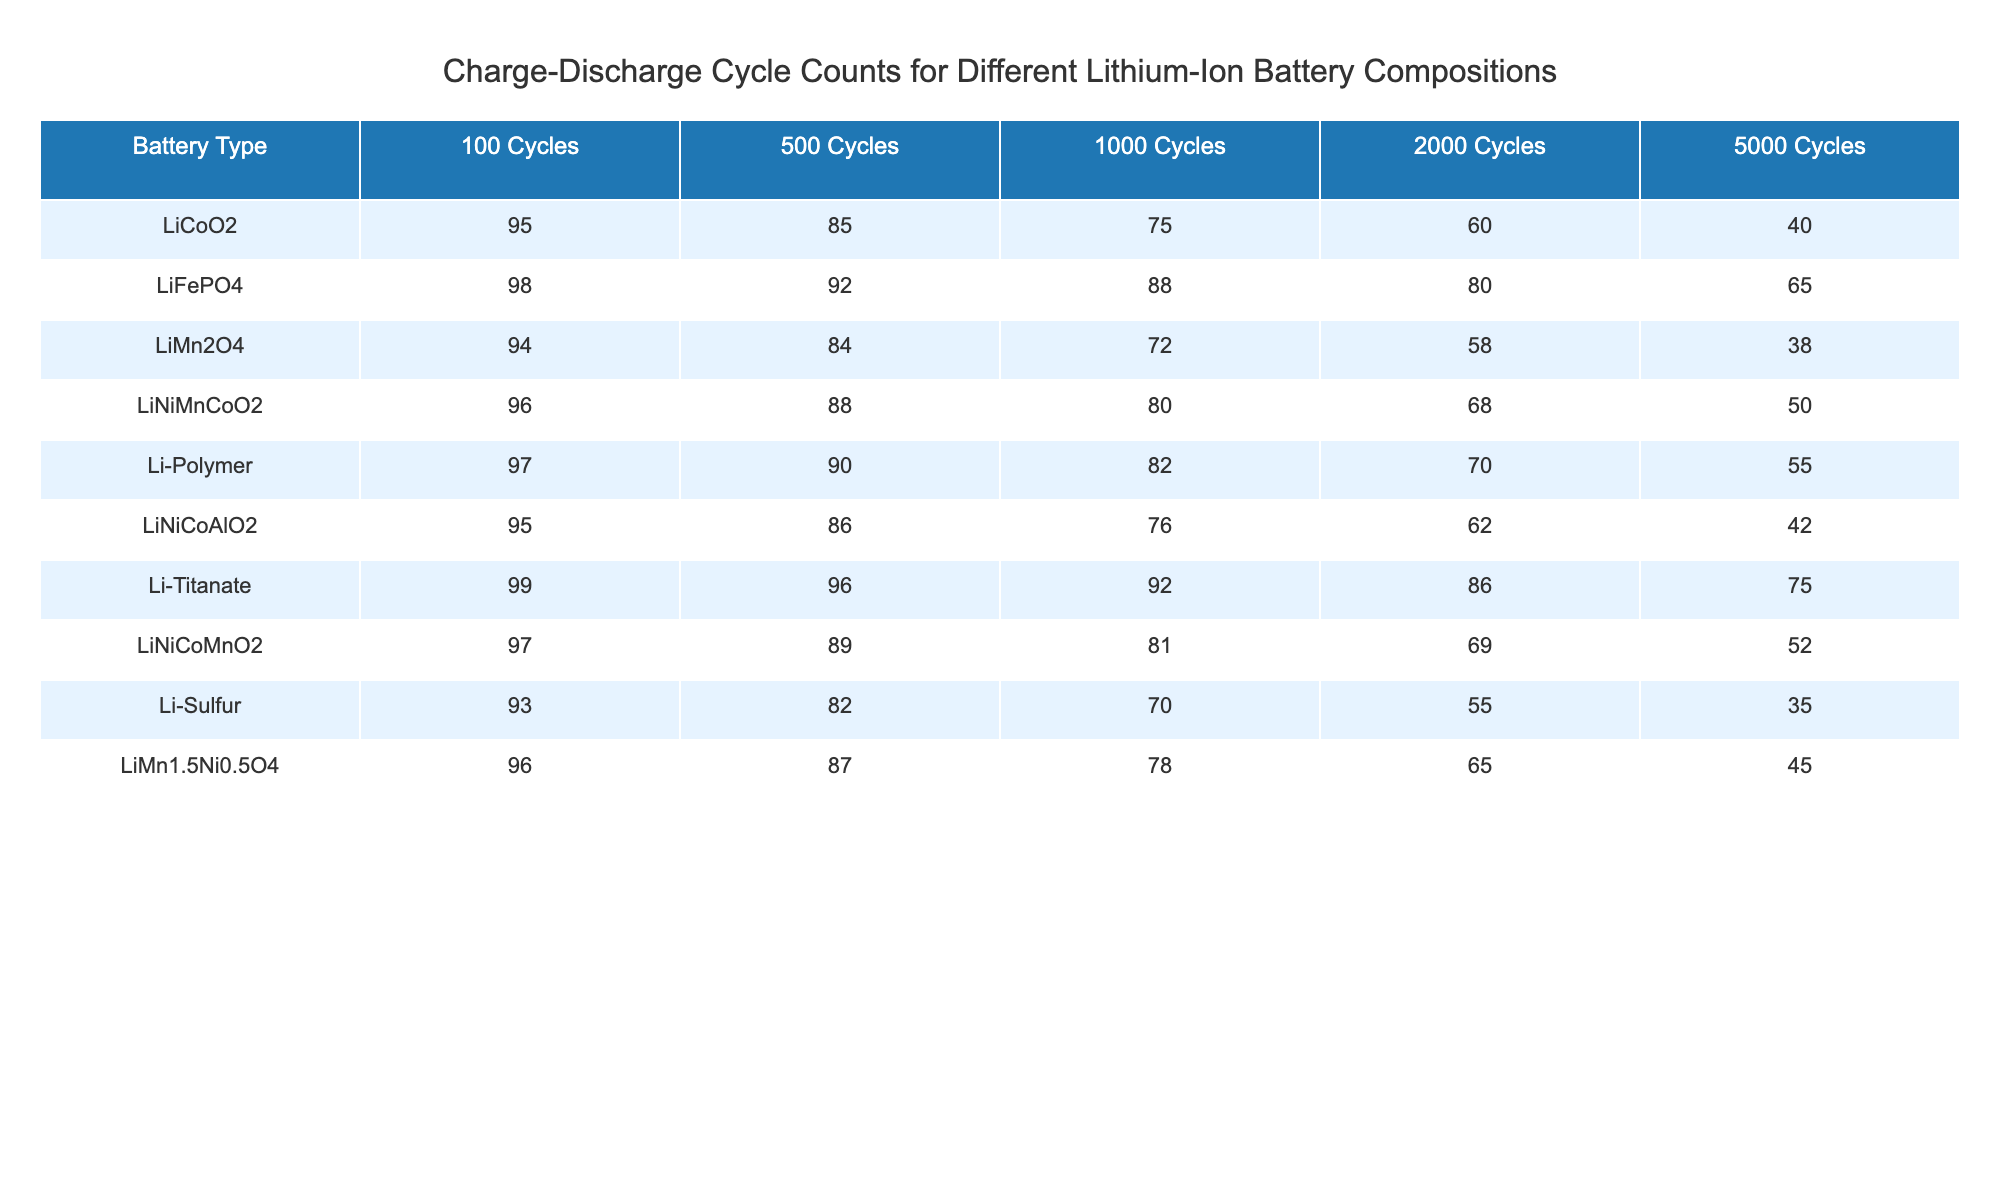What is the charge-discharge cycle count for LiFePO4 after 1000 cycles? Looking at the column for 1000 cycles under the LiFePO4 row, the value is 88.
Answer: 88 Which battery type has the highest cycle count after 5000 cycles? Checking the last column (5000 cycles) for each battery type, Li-Titanate shows the highest value at 75.
Answer: Li-Titanate What is the difference in cycle count at 2000 cycles between LiMn2O4 and LiNiCoMnO2? For LiMn2O4, the cycle count at 2000 cycles is 58, and for LiNiCoMnO2, it is 69. The difference is 69 - 58 = 11.
Answer: 11 Is it true that Li-Sulfur has a higher cycle count at 500 cycles compared to LiNiMnCoO2? Li-Sulfur has a cycle count of 82 at 500 cycles, while LiNiMnCoO2 has a count of 88. Since 82 is less than 88, the statement is false.
Answer: No What is the average cycle count for LiCoO2 across all cycle counts listed? To find the average, add all cycle counts for LiCoO2: 95 + 85 + 75 + 60 + 40 = 455. Then divide by the number of cycles (5): 455 / 5 = 91.
Answer: 91 Which battery type shows the largest decrease in cycle count from 100 cycles to 5000 cycles? By comparing the values: LiCoO2 decreases from 95 to 40 (55), LiFePO4 from 98 to 65 (33), etc. The largest decrease is by LiCoO2, with a total decline of 55.
Answer: LiCoO2 What is the median cycle count for all battery types at 100 cycles? Listing the cycle counts at 100 cycles: 95, 98, 94, 96, 97, 95, 99, 97, 93, 96. Sorting these gives: 93, 94, 95, 95, 96, 96, 97, 97, 98, 99. The median is the average of the 5th and 6th values, (96 + 96) / 2 = 96.
Answer: 96 Is Li-Polymer consistently performing better than LiMn2O4 across all cycle counts? Checking each cycle count: Li-Polymer has 97 > 94, 90 > 84, 82 > 72, 70 > 58, and 55 > 38. Since Li-Polymer is greater in all counts compared to LiMn2O4, the statement is true.
Answer: Yes What is the total cycle count for LiNiCoAlO2 over all cycles? Adding the values for LiNiCoAlO2: 95 + 86 + 76 + 62 + 42 = 361.
Answer: 361 Which battery type has the lowest cycle count after 2000 cycles? Looking at the 2000 cycles column, Li-Sulfur shows the lowest count of 55.
Answer: Li-Sulfur 